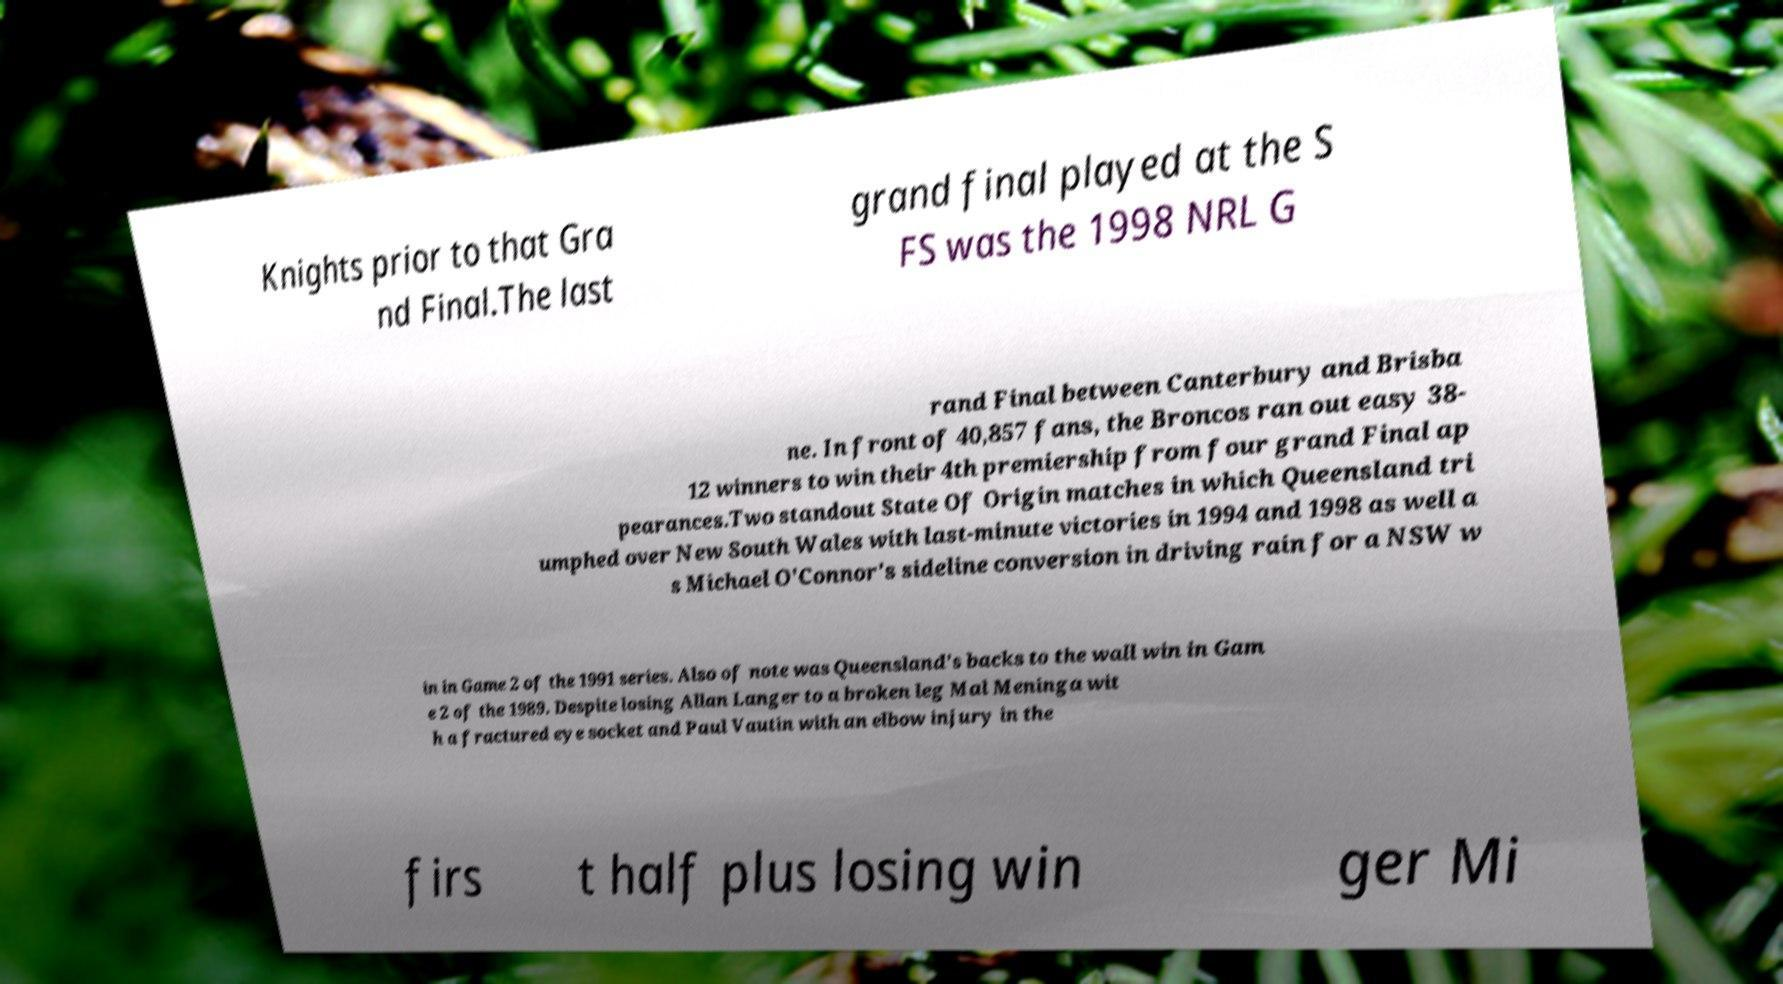Please identify and transcribe the text found in this image. Knights prior to that Gra nd Final.The last grand final played at the S FS was the 1998 NRL G rand Final between Canterbury and Brisba ne. In front of 40,857 fans, the Broncos ran out easy 38- 12 winners to win their 4th premiership from four grand Final ap pearances.Two standout State Of Origin matches in which Queensland tri umphed over New South Wales with last-minute victories in 1994 and 1998 as well a s Michael O'Connor's sideline conversion in driving rain for a NSW w in in Game 2 of the 1991 series. Also of note was Queensland's backs to the wall win in Gam e 2 of the 1989. Despite losing Allan Langer to a broken leg Mal Meninga wit h a fractured eye socket and Paul Vautin with an elbow injury in the firs t half plus losing win ger Mi 